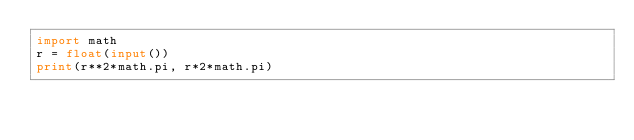Convert code to text. <code><loc_0><loc_0><loc_500><loc_500><_Python_>import math
r = float(input())
print(r**2*math.pi, r*2*math.pi)</code> 